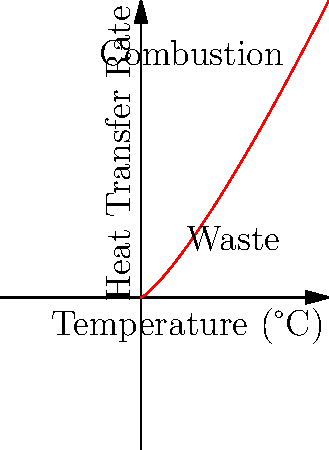In a waste-to-energy incinerator, the heat transfer rate increases non-linearly with temperature. Given that the heat transfer rate ($Q$) is related to temperature ($T$) by the equation $Q = kT^n$, where $k$ is a constant and $n$ is the power law exponent, what is the approximate value of $n$ based on the graph? To determine the power law exponent $n$, we need to analyze the relationship between temperature and heat transfer rate shown in the graph. Here's how we can approach this:

1. Recall the power law equation: $Q = kT^n$

2. Taking the logarithm of both sides:
   $\log Q = \log k + n \log T$

3. This is in the form of a straight line ($y = mx + b$) when plotted on a log-log scale, where $n$ is the slope.

4. Although the graph is not on a log-log scale, we can still estimate the slope by looking at how quickly the heat transfer rate increases with temperature.

5. The curve is steeper than a linear relationship (which would have $n = 1$) but less steep than a quadratic relationship (which would have $n = 2$).

6. The curve appears to be closer to $n = 1.25$, as it increases more rapidly than linear but not as rapidly as quadratic.

7. This value of $n > 1$ indicates that the heat transfer becomes more efficient at higher temperatures, which is typical for radiation-dominated heat transfer in incinerators.

Therefore, based on the graph, the approximate value of the power law exponent $n$ is 1.25.
Answer: $n \approx 1.25$ 